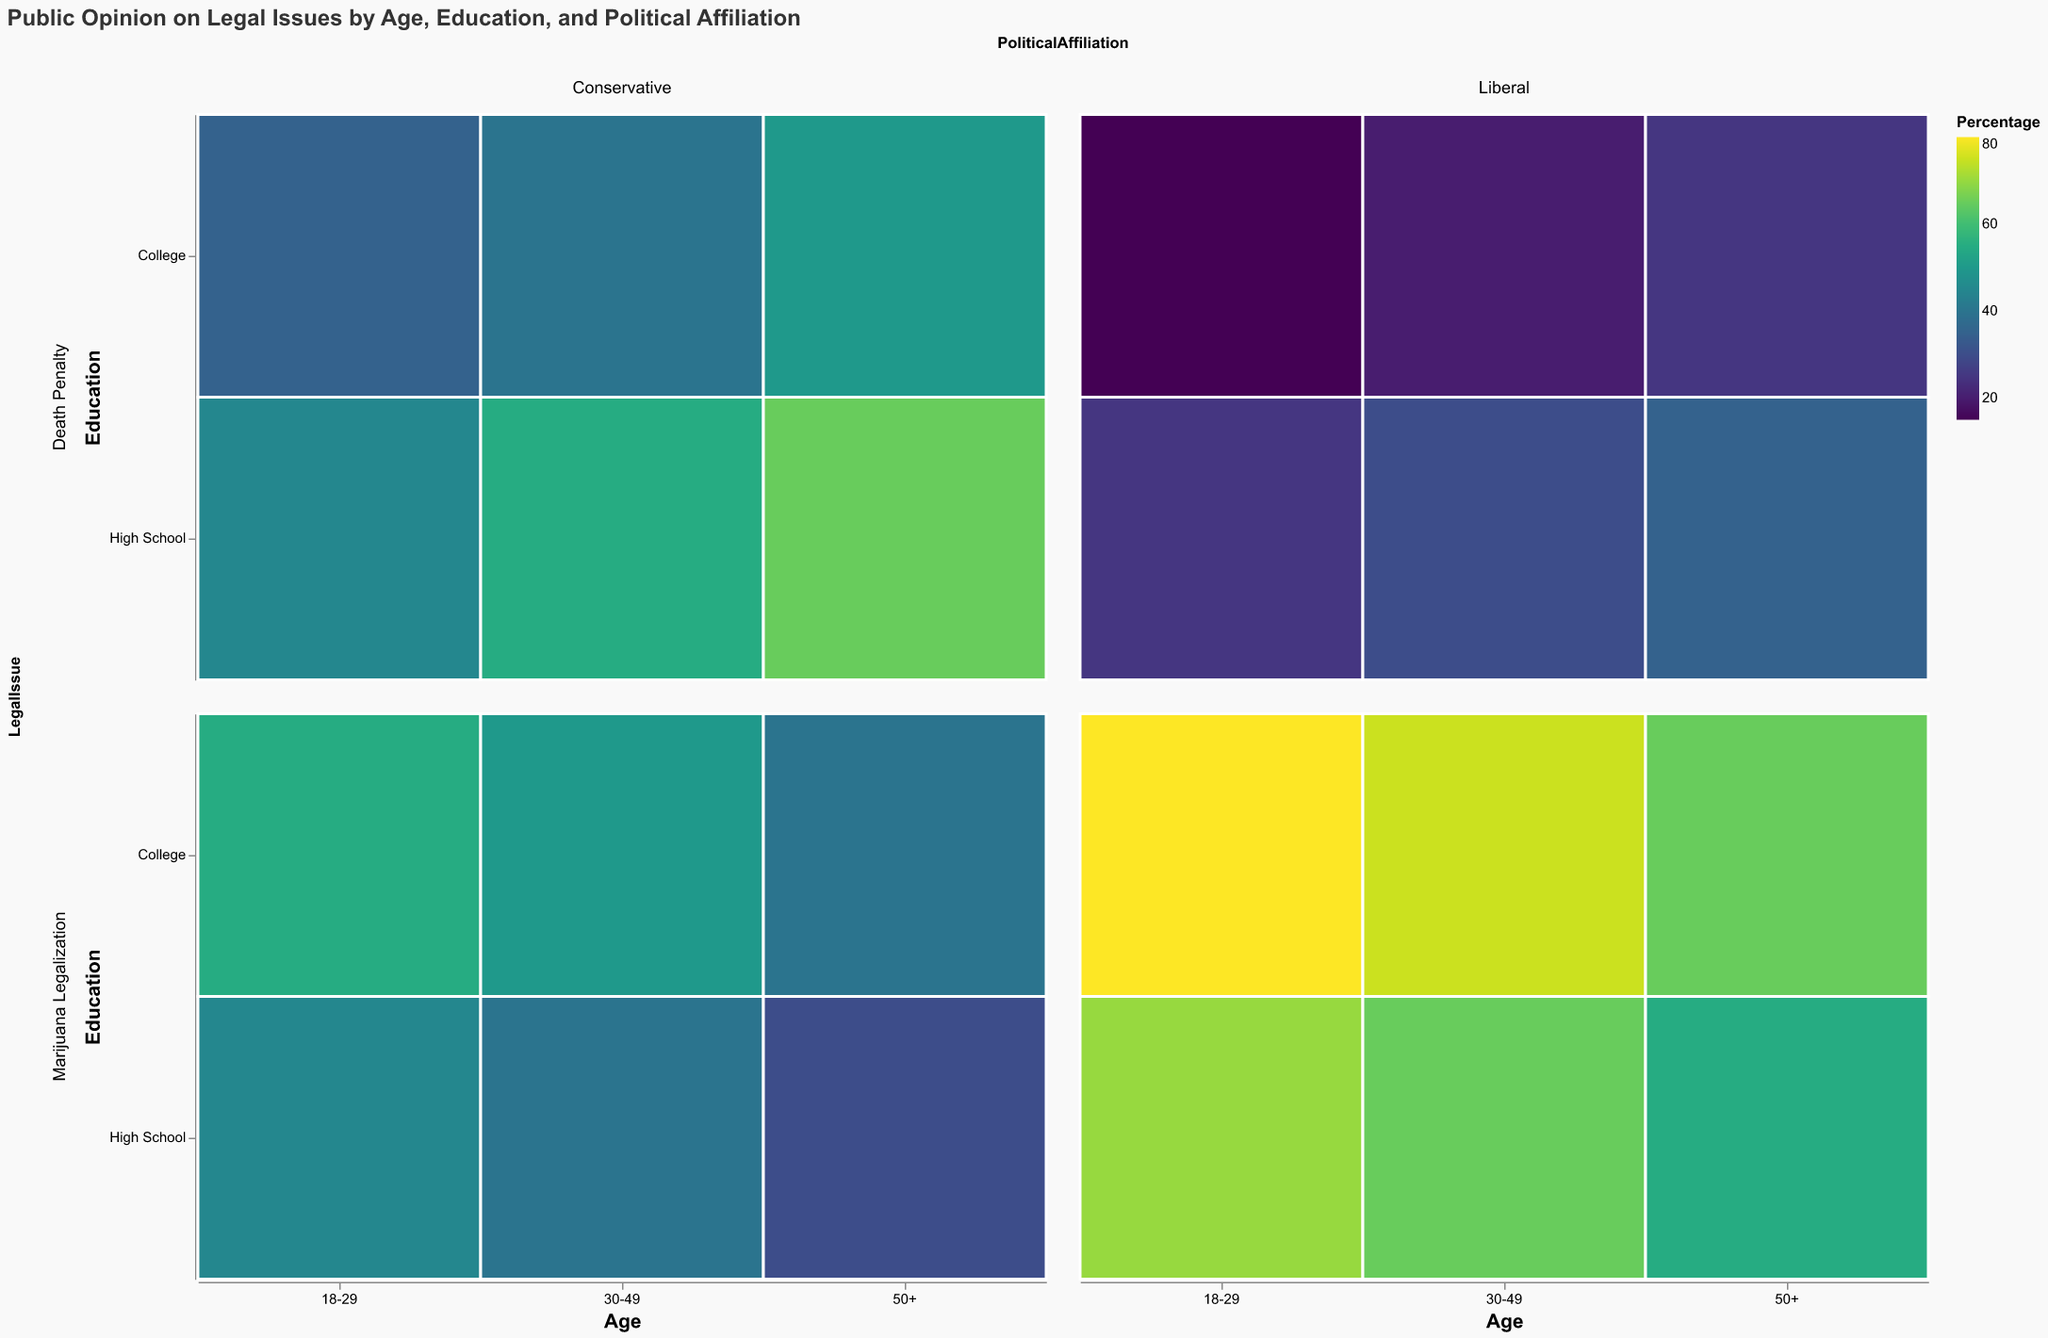What is the title of the mosaic plot? The title is displayed at the top of the plot and summarizes the content of the chart. It helps in understanding the context of the data being visualized.
Answer: Public Opinion on Legal Issues by Age, Education, and Political Affiliation Which age group has the highest percentage of liberals in favor of marijuana legalization at the college education level? To find this, look at the row for marijuana legalization and the columns and rows corresponding to liberals and college education, then compare across the different age segments.
Answer: 18-29 How does support for the death penalty differ between liberals and conservatives with a high school education in the age group 50+? Compare the percentages for liberals and conservatives within the high school education level in the 50+ age group by inspecting the color intensity and corresponding values.
Answer: Liberals: 35%, Conservatives: 65% Which combination shows the least support for marijuana legalization, and what is that percentage? Look throughout the marijuana legalization row for the lowest percentage value by comparing the color intensities and identifying the lowest numerical value.
Answer: 50+, High School, Conservative, 30% Is there a higher percentage of liberal college-educated individuals in favor of the death penalty or marijuana legalization in the 30-49 age group? Compare the percentages by looking at the row for the 30-49 age group, college education, and liberal section within both legal issues.
Answer: Marijuana Legalization: 75%, Death Penalty: 20% What is the difference in support for marijuana legalization between conservative high school graduates and conservative college graduates aged 18-29? Find the percentages for each respective group and compute the difference.
Answer: 55% (College) - 45% (High School) = 10% In the dataset, who shows more support for the death penalty: conservative individuals aged 30-49 with high school education, or the same group aged 50+? Compare the values for the two specified groups by looking at the death penalty row and noting the percentages.
Answer: 30-49: 55%, 50+: 65% Which demographic shows the least support for the death penalty and how much percentage they support it with college education level? Look for the lowest percentage in the death penalty row within the college education column, noting the associated demographic group.
Answer: 18-29, Liberal, 15% Sort the age groups seeing higher percentages for conservative college-educated individuals supporting marijuana legalization in ascending order. Compare the percentages for conservatives with college education supporting marijuana legalization in each age group and list them in ascending order.
Answer: 50+ (40%), 30-49 (50%), 18-29 (55%) 